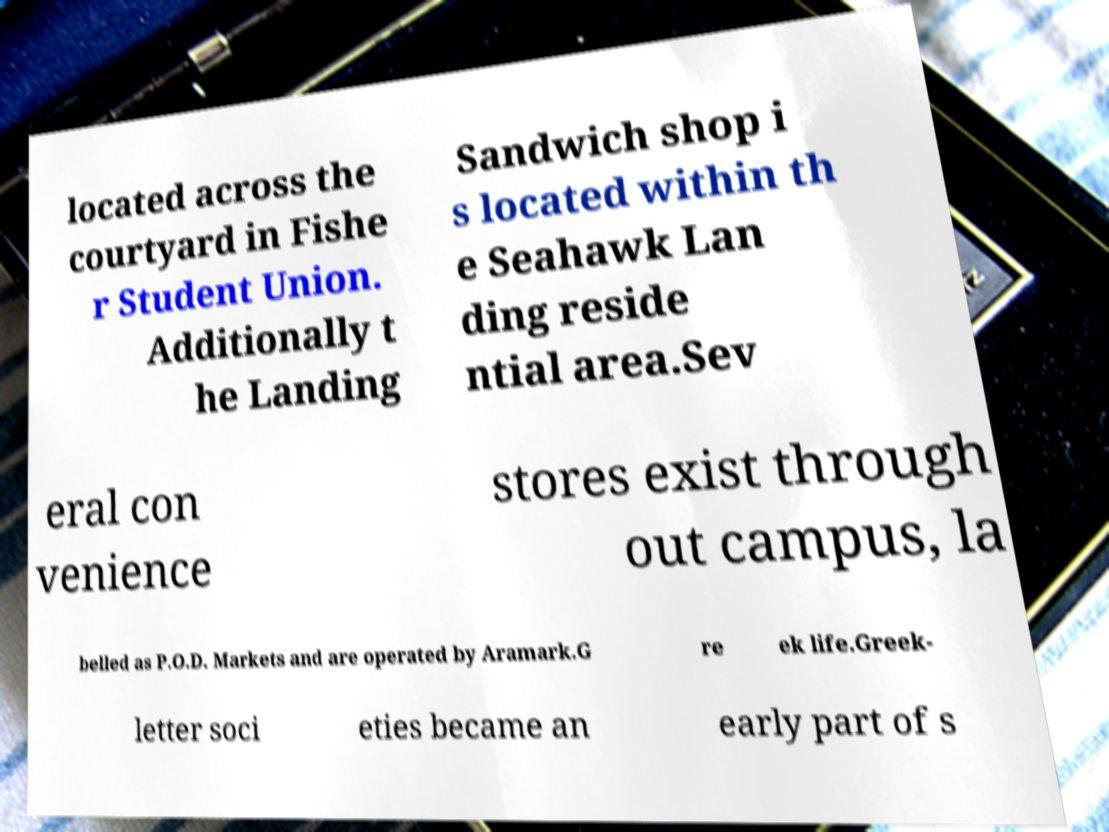Could you assist in decoding the text presented in this image and type it out clearly? located across the courtyard in Fishe r Student Union. Additionally t he Landing Sandwich shop i s located within th e Seahawk Lan ding reside ntial area.Sev eral con venience stores exist through out campus, la belled as P.O.D. Markets and are operated by Aramark.G re ek life.Greek- letter soci eties became an early part of s 